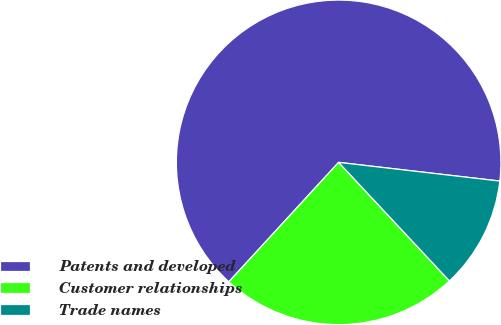Convert chart. <chart><loc_0><loc_0><loc_500><loc_500><pie_chart><fcel>Patents and developed<fcel>Customer relationships<fcel>Trade names<nl><fcel>65.01%<fcel>23.79%<fcel>11.2%<nl></chart> 